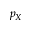<formula> <loc_0><loc_0><loc_500><loc_500>p _ { X }</formula> 